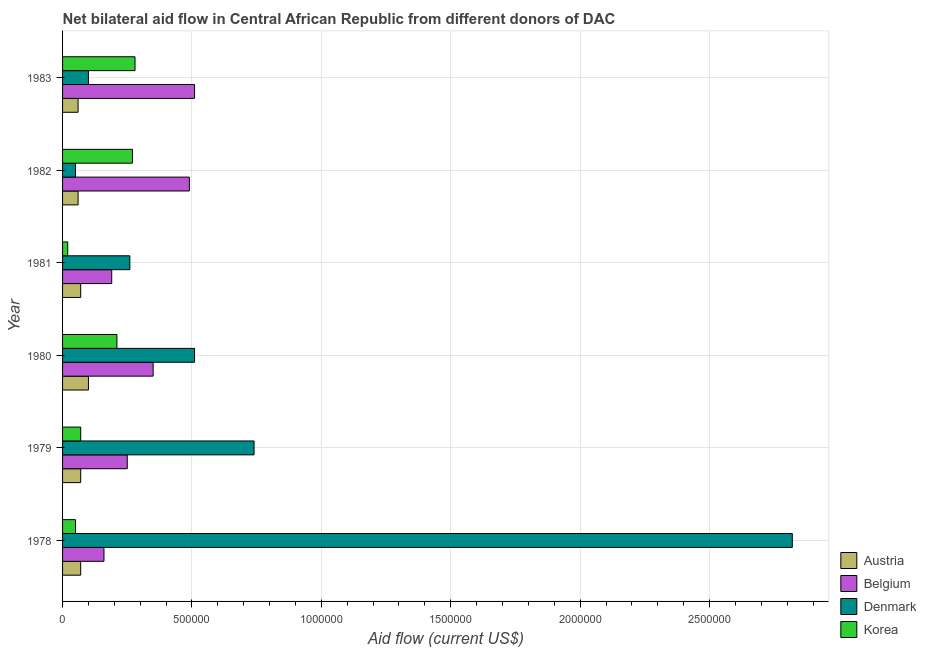Are the number of bars per tick equal to the number of legend labels?
Give a very brief answer. Yes. How many bars are there on the 4th tick from the top?
Provide a short and direct response. 4. How many bars are there on the 1st tick from the bottom?
Provide a short and direct response. 4. What is the amount of aid given by belgium in 1981?
Your answer should be very brief. 1.90e+05. Across all years, what is the maximum amount of aid given by austria?
Your answer should be very brief. 1.00e+05. Across all years, what is the minimum amount of aid given by korea?
Your answer should be compact. 2.00e+04. In which year was the amount of aid given by belgium maximum?
Offer a very short reply. 1983. In which year was the amount of aid given by korea minimum?
Your answer should be very brief. 1981. What is the total amount of aid given by austria in the graph?
Provide a succinct answer. 4.30e+05. What is the difference between the amount of aid given by belgium in 1980 and that in 1982?
Your answer should be compact. -1.40e+05. What is the difference between the amount of aid given by austria in 1982 and the amount of aid given by belgium in 1983?
Your response must be concise. -4.50e+05. What is the average amount of aid given by belgium per year?
Give a very brief answer. 3.25e+05. In the year 1981, what is the difference between the amount of aid given by austria and amount of aid given by denmark?
Provide a succinct answer. -1.90e+05. In how many years, is the amount of aid given by korea greater than 2200000 US$?
Provide a succinct answer. 0. What is the ratio of the amount of aid given by denmark in 1978 to that in 1982?
Your response must be concise. 56.4. Is the amount of aid given by korea in 1982 less than that in 1983?
Offer a terse response. Yes. Is the difference between the amount of aid given by austria in 1980 and 1982 greater than the difference between the amount of aid given by belgium in 1980 and 1982?
Provide a succinct answer. Yes. What is the difference between the highest and the lowest amount of aid given by belgium?
Your answer should be compact. 3.50e+05. In how many years, is the amount of aid given by austria greater than the average amount of aid given by austria taken over all years?
Give a very brief answer. 1. Is it the case that in every year, the sum of the amount of aid given by denmark and amount of aid given by korea is greater than the sum of amount of aid given by austria and amount of aid given by belgium?
Keep it short and to the point. No. What does the 2nd bar from the bottom in 1981 represents?
Your answer should be very brief. Belgium. Is it the case that in every year, the sum of the amount of aid given by austria and amount of aid given by belgium is greater than the amount of aid given by denmark?
Give a very brief answer. No. How many bars are there?
Your answer should be compact. 24. What is the difference between two consecutive major ticks on the X-axis?
Offer a very short reply. 5.00e+05. Does the graph contain grids?
Provide a short and direct response. Yes. Where does the legend appear in the graph?
Make the answer very short. Bottom right. What is the title of the graph?
Offer a terse response. Net bilateral aid flow in Central African Republic from different donors of DAC. What is the label or title of the Y-axis?
Your response must be concise. Year. What is the Aid flow (current US$) of Denmark in 1978?
Provide a succinct answer. 2.82e+06. What is the Aid flow (current US$) of Korea in 1978?
Your answer should be very brief. 5.00e+04. What is the Aid flow (current US$) in Denmark in 1979?
Your answer should be compact. 7.40e+05. What is the Aid flow (current US$) in Denmark in 1980?
Your response must be concise. 5.10e+05. What is the Aid flow (current US$) of Belgium in 1981?
Provide a short and direct response. 1.90e+05. What is the Aid flow (current US$) in Denmark in 1981?
Your answer should be very brief. 2.60e+05. What is the Aid flow (current US$) in Austria in 1982?
Offer a very short reply. 6.00e+04. What is the Aid flow (current US$) in Belgium in 1982?
Offer a very short reply. 4.90e+05. What is the Aid flow (current US$) in Denmark in 1982?
Your answer should be very brief. 5.00e+04. What is the Aid flow (current US$) in Korea in 1982?
Keep it short and to the point. 2.70e+05. What is the Aid flow (current US$) in Austria in 1983?
Your response must be concise. 6.00e+04. What is the Aid flow (current US$) in Belgium in 1983?
Ensure brevity in your answer.  5.10e+05. Across all years, what is the maximum Aid flow (current US$) in Austria?
Offer a terse response. 1.00e+05. Across all years, what is the maximum Aid flow (current US$) of Belgium?
Make the answer very short. 5.10e+05. Across all years, what is the maximum Aid flow (current US$) in Denmark?
Make the answer very short. 2.82e+06. Across all years, what is the maximum Aid flow (current US$) of Korea?
Offer a very short reply. 2.80e+05. Across all years, what is the minimum Aid flow (current US$) in Austria?
Your answer should be very brief. 6.00e+04. Across all years, what is the minimum Aid flow (current US$) of Denmark?
Your answer should be very brief. 5.00e+04. Across all years, what is the minimum Aid flow (current US$) of Korea?
Provide a succinct answer. 2.00e+04. What is the total Aid flow (current US$) of Austria in the graph?
Offer a very short reply. 4.30e+05. What is the total Aid flow (current US$) in Belgium in the graph?
Ensure brevity in your answer.  1.95e+06. What is the total Aid flow (current US$) of Denmark in the graph?
Keep it short and to the point. 4.48e+06. What is the difference between the Aid flow (current US$) of Austria in 1978 and that in 1979?
Ensure brevity in your answer.  0. What is the difference between the Aid flow (current US$) of Belgium in 1978 and that in 1979?
Offer a very short reply. -9.00e+04. What is the difference between the Aid flow (current US$) of Denmark in 1978 and that in 1979?
Give a very brief answer. 2.08e+06. What is the difference between the Aid flow (current US$) of Austria in 1978 and that in 1980?
Your answer should be compact. -3.00e+04. What is the difference between the Aid flow (current US$) in Belgium in 1978 and that in 1980?
Make the answer very short. -1.90e+05. What is the difference between the Aid flow (current US$) in Denmark in 1978 and that in 1980?
Your answer should be very brief. 2.31e+06. What is the difference between the Aid flow (current US$) in Korea in 1978 and that in 1980?
Your answer should be very brief. -1.60e+05. What is the difference between the Aid flow (current US$) in Denmark in 1978 and that in 1981?
Keep it short and to the point. 2.56e+06. What is the difference between the Aid flow (current US$) in Korea in 1978 and that in 1981?
Ensure brevity in your answer.  3.00e+04. What is the difference between the Aid flow (current US$) in Austria in 1978 and that in 1982?
Make the answer very short. 10000. What is the difference between the Aid flow (current US$) of Belgium in 1978 and that in 1982?
Offer a terse response. -3.30e+05. What is the difference between the Aid flow (current US$) of Denmark in 1978 and that in 1982?
Ensure brevity in your answer.  2.77e+06. What is the difference between the Aid flow (current US$) in Korea in 1978 and that in 1982?
Make the answer very short. -2.20e+05. What is the difference between the Aid flow (current US$) in Belgium in 1978 and that in 1983?
Your response must be concise. -3.50e+05. What is the difference between the Aid flow (current US$) in Denmark in 1978 and that in 1983?
Offer a very short reply. 2.72e+06. What is the difference between the Aid flow (current US$) of Belgium in 1979 and that in 1980?
Provide a short and direct response. -1.00e+05. What is the difference between the Aid flow (current US$) in Denmark in 1979 and that in 1980?
Provide a succinct answer. 2.30e+05. What is the difference between the Aid flow (current US$) of Korea in 1979 and that in 1980?
Make the answer very short. -1.40e+05. What is the difference between the Aid flow (current US$) in Austria in 1979 and that in 1981?
Your answer should be compact. 0. What is the difference between the Aid flow (current US$) in Austria in 1979 and that in 1982?
Your answer should be very brief. 10000. What is the difference between the Aid flow (current US$) of Belgium in 1979 and that in 1982?
Ensure brevity in your answer.  -2.40e+05. What is the difference between the Aid flow (current US$) in Denmark in 1979 and that in 1982?
Provide a short and direct response. 6.90e+05. What is the difference between the Aid flow (current US$) of Korea in 1979 and that in 1982?
Offer a terse response. -2.00e+05. What is the difference between the Aid flow (current US$) of Austria in 1979 and that in 1983?
Your response must be concise. 10000. What is the difference between the Aid flow (current US$) of Belgium in 1979 and that in 1983?
Ensure brevity in your answer.  -2.60e+05. What is the difference between the Aid flow (current US$) in Denmark in 1979 and that in 1983?
Your response must be concise. 6.40e+05. What is the difference between the Aid flow (current US$) in Korea in 1979 and that in 1983?
Offer a terse response. -2.10e+05. What is the difference between the Aid flow (current US$) of Austria in 1980 and that in 1981?
Your answer should be compact. 3.00e+04. What is the difference between the Aid flow (current US$) of Belgium in 1980 and that in 1982?
Ensure brevity in your answer.  -1.40e+05. What is the difference between the Aid flow (current US$) of Denmark in 1980 and that in 1982?
Offer a very short reply. 4.60e+05. What is the difference between the Aid flow (current US$) in Korea in 1980 and that in 1982?
Give a very brief answer. -6.00e+04. What is the difference between the Aid flow (current US$) of Austria in 1980 and that in 1983?
Your answer should be very brief. 4.00e+04. What is the difference between the Aid flow (current US$) in Belgium in 1980 and that in 1983?
Give a very brief answer. -1.60e+05. What is the difference between the Aid flow (current US$) of Denmark in 1980 and that in 1983?
Give a very brief answer. 4.10e+05. What is the difference between the Aid flow (current US$) in Korea in 1981 and that in 1982?
Keep it short and to the point. -2.50e+05. What is the difference between the Aid flow (current US$) of Belgium in 1981 and that in 1983?
Provide a succinct answer. -3.20e+05. What is the difference between the Aid flow (current US$) in Korea in 1981 and that in 1983?
Keep it short and to the point. -2.60e+05. What is the difference between the Aid flow (current US$) in Austria in 1982 and that in 1983?
Your answer should be very brief. 0. What is the difference between the Aid flow (current US$) in Austria in 1978 and the Aid flow (current US$) in Denmark in 1979?
Give a very brief answer. -6.70e+05. What is the difference between the Aid flow (current US$) in Belgium in 1978 and the Aid flow (current US$) in Denmark in 1979?
Ensure brevity in your answer.  -5.80e+05. What is the difference between the Aid flow (current US$) of Belgium in 1978 and the Aid flow (current US$) of Korea in 1979?
Your answer should be very brief. 9.00e+04. What is the difference between the Aid flow (current US$) of Denmark in 1978 and the Aid flow (current US$) of Korea in 1979?
Make the answer very short. 2.75e+06. What is the difference between the Aid flow (current US$) of Austria in 1978 and the Aid flow (current US$) of Belgium in 1980?
Offer a terse response. -2.80e+05. What is the difference between the Aid flow (current US$) in Austria in 1978 and the Aid flow (current US$) in Denmark in 1980?
Make the answer very short. -4.40e+05. What is the difference between the Aid flow (current US$) in Belgium in 1978 and the Aid flow (current US$) in Denmark in 1980?
Your answer should be compact. -3.50e+05. What is the difference between the Aid flow (current US$) in Denmark in 1978 and the Aid flow (current US$) in Korea in 1980?
Keep it short and to the point. 2.61e+06. What is the difference between the Aid flow (current US$) of Belgium in 1978 and the Aid flow (current US$) of Denmark in 1981?
Your answer should be very brief. -1.00e+05. What is the difference between the Aid flow (current US$) of Denmark in 1978 and the Aid flow (current US$) of Korea in 1981?
Your answer should be very brief. 2.80e+06. What is the difference between the Aid flow (current US$) of Austria in 1978 and the Aid flow (current US$) of Belgium in 1982?
Provide a succinct answer. -4.20e+05. What is the difference between the Aid flow (current US$) of Austria in 1978 and the Aid flow (current US$) of Denmark in 1982?
Provide a short and direct response. 2.00e+04. What is the difference between the Aid flow (current US$) in Belgium in 1978 and the Aid flow (current US$) in Denmark in 1982?
Your answer should be very brief. 1.10e+05. What is the difference between the Aid flow (current US$) in Denmark in 1978 and the Aid flow (current US$) in Korea in 1982?
Provide a short and direct response. 2.55e+06. What is the difference between the Aid flow (current US$) of Austria in 1978 and the Aid flow (current US$) of Belgium in 1983?
Offer a terse response. -4.40e+05. What is the difference between the Aid flow (current US$) in Denmark in 1978 and the Aid flow (current US$) in Korea in 1983?
Keep it short and to the point. 2.54e+06. What is the difference between the Aid flow (current US$) in Austria in 1979 and the Aid flow (current US$) in Belgium in 1980?
Your answer should be compact. -2.80e+05. What is the difference between the Aid flow (current US$) of Austria in 1979 and the Aid flow (current US$) of Denmark in 1980?
Offer a very short reply. -4.40e+05. What is the difference between the Aid flow (current US$) in Belgium in 1979 and the Aid flow (current US$) in Korea in 1980?
Offer a terse response. 4.00e+04. What is the difference between the Aid flow (current US$) in Denmark in 1979 and the Aid flow (current US$) in Korea in 1980?
Offer a very short reply. 5.30e+05. What is the difference between the Aid flow (current US$) in Austria in 1979 and the Aid flow (current US$) in Denmark in 1981?
Give a very brief answer. -1.90e+05. What is the difference between the Aid flow (current US$) of Belgium in 1979 and the Aid flow (current US$) of Denmark in 1981?
Your answer should be very brief. -10000. What is the difference between the Aid flow (current US$) in Denmark in 1979 and the Aid flow (current US$) in Korea in 1981?
Keep it short and to the point. 7.20e+05. What is the difference between the Aid flow (current US$) of Austria in 1979 and the Aid flow (current US$) of Belgium in 1982?
Offer a terse response. -4.20e+05. What is the difference between the Aid flow (current US$) in Austria in 1979 and the Aid flow (current US$) in Denmark in 1982?
Give a very brief answer. 2.00e+04. What is the difference between the Aid flow (current US$) of Austria in 1979 and the Aid flow (current US$) of Korea in 1982?
Your response must be concise. -2.00e+05. What is the difference between the Aid flow (current US$) in Belgium in 1979 and the Aid flow (current US$) in Denmark in 1982?
Ensure brevity in your answer.  2.00e+05. What is the difference between the Aid flow (current US$) of Denmark in 1979 and the Aid flow (current US$) of Korea in 1982?
Keep it short and to the point. 4.70e+05. What is the difference between the Aid flow (current US$) of Austria in 1979 and the Aid flow (current US$) of Belgium in 1983?
Give a very brief answer. -4.40e+05. What is the difference between the Aid flow (current US$) in Belgium in 1979 and the Aid flow (current US$) in Denmark in 1983?
Make the answer very short. 1.50e+05. What is the difference between the Aid flow (current US$) of Austria in 1980 and the Aid flow (current US$) of Denmark in 1981?
Provide a short and direct response. -1.60e+05. What is the difference between the Aid flow (current US$) in Austria in 1980 and the Aid flow (current US$) in Korea in 1981?
Ensure brevity in your answer.  8.00e+04. What is the difference between the Aid flow (current US$) in Belgium in 1980 and the Aid flow (current US$) in Denmark in 1981?
Keep it short and to the point. 9.00e+04. What is the difference between the Aid flow (current US$) in Denmark in 1980 and the Aid flow (current US$) in Korea in 1981?
Offer a very short reply. 4.90e+05. What is the difference between the Aid flow (current US$) of Austria in 1980 and the Aid flow (current US$) of Belgium in 1982?
Your answer should be very brief. -3.90e+05. What is the difference between the Aid flow (current US$) in Austria in 1980 and the Aid flow (current US$) in Korea in 1982?
Give a very brief answer. -1.70e+05. What is the difference between the Aid flow (current US$) of Belgium in 1980 and the Aid flow (current US$) of Denmark in 1982?
Offer a very short reply. 3.00e+05. What is the difference between the Aid flow (current US$) of Austria in 1980 and the Aid flow (current US$) of Belgium in 1983?
Offer a terse response. -4.10e+05. What is the difference between the Aid flow (current US$) in Austria in 1980 and the Aid flow (current US$) in Denmark in 1983?
Offer a terse response. 0. What is the difference between the Aid flow (current US$) of Austria in 1980 and the Aid flow (current US$) of Korea in 1983?
Your answer should be very brief. -1.80e+05. What is the difference between the Aid flow (current US$) in Denmark in 1980 and the Aid flow (current US$) in Korea in 1983?
Keep it short and to the point. 2.30e+05. What is the difference between the Aid flow (current US$) in Austria in 1981 and the Aid flow (current US$) in Belgium in 1982?
Your answer should be very brief. -4.20e+05. What is the difference between the Aid flow (current US$) in Austria in 1981 and the Aid flow (current US$) in Korea in 1982?
Ensure brevity in your answer.  -2.00e+05. What is the difference between the Aid flow (current US$) of Belgium in 1981 and the Aid flow (current US$) of Korea in 1982?
Make the answer very short. -8.00e+04. What is the difference between the Aid flow (current US$) in Denmark in 1981 and the Aid flow (current US$) in Korea in 1982?
Your response must be concise. -10000. What is the difference between the Aid flow (current US$) in Austria in 1981 and the Aid flow (current US$) in Belgium in 1983?
Offer a very short reply. -4.40e+05. What is the difference between the Aid flow (current US$) of Austria in 1981 and the Aid flow (current US$) of Korea in 1983?
Give a very brief answer. -2.10e+05. What is the difference between the Aid flow (current US$) of Belgium in 1981 and the Aid flow (current US$) of Denmark in 1983?
Provide a short and direct response. 9.00e+04. What is the difference between the Aid flow (current US$) of Denmark in 1981 and the Aid flow (current US$) of Korea in 1983?
Provide a succinct answer. -2.00e+04. What is the difference between the Aid flow (current US$) in Austria in 1982 and the Aid flow (current US$) in Belgium in 1983?
Your response must be concise. -4.50e+05. What is the difference between the Aid flow (current US$) of Belgium in 1982 and the Aid flow (current US$) of Korea in 1983?
Your answer should be compact. 2.10e+05. What is the difference between the Aid flow (current US$) in Denmark in 1982 and the Aid flow (current US$) in Korea in 1983?
Make the answer very short. -2.30e+05. What is the average Aid flow (current US$) of Austria per year?
Your answer should be very brief. 7.17e+04. What is the average Aid flow (current US$) in Belgium per year?
Make the answer very short. 3.25e+05. What is the average Aid flow (current US$) of Denmark per year?
Offer a terse response. 7.47e+05. In the year 1978, what is the difference between the Aid flow (current US$) of Austria and Aid flow (current US$) of Belgium?
Give a very brief answer. -9.00e+04. In the year 1978, what is the difference between the Aid flow (current US$) in Austria and Aid flow (current US$) in Denmark?
Offer a terse response. -2.75e+06. In the year 1978, what is the difference between the Aid flow (current US$) in Belgium and Aid flow (current US$) in Denmark?
Offer a terse response. -2.66e+06. In the year 1978, what is the difference between the Aid flow (current US$) in Denmark and Aid flow (current US$) in Korea?
Give a very brief answer. 2.77e+06. In the year 1979, what is the difference between the Aid flow (current US$) in Austria and Aid flow (current US$) in Denmark?
Offer a very short reply. -6.70e+05. In the year 1979, what is the difference between the Aid flow (current US$) in Austria and Aid flow (current US$) in Korea?
Ensure brevity in your answer.  0. In the year 1979, what is the difference between the Aid flow (current US$) in Belgium and Aid flow (current US$) in Denmark?
Offer a terse response. -4.90e+05. In the year 1979, what is the difference between the Aid flow (current US$) of Belgium and Aid flow (current US$) of Korea?
Make the answer very short. 1.80e+05. In the year 1979, what is the difference between the Aid flow (current US$) of Denmark and Aid flow (current US$) of Korea?
Give a very brief answer. 6.70e+05. In the year 1980, what is the difference between the Aid flow (current US$) in Austria and Aid flow (current US$) in Denmark?
Your response must be concise. -4.10e+05. In the year 1980, what is the difference between the Aid flow (current US$) of Belgium and Aid flow (current US$) of Denmark?
Offer a terse response. -1.60e+05. In the year 1980, what is the difference between the Aid flow (current US$) of Belgium and Aid flow (current US$) of Korea?
Offer a very short reply. 1.40e+05. In the year 1980, what is the difference between the Aid flow (current US$) in Denmark and Aid flow (current US$) in Korea?
Make the answer very short. 3.00e+05. In the year 1981, what is the difference between the Aid flow (current US$) of Austria and Aid flow (current US$) of Belgium?
Your answer should be compact. -1.20e+05. In the year 1981, what is the difference between the Aid flow (current US$) of Belgium and Aid flow (current US$) of Denmark?
Offer a terse response. -7.00e+04. In the year 1982, what is the difference between the Aid flow (current US$) in Austria and Aid flow (current US$) in Belgium?
Your answer should be compact. -4.30e+05. In the year 1982, what is the difference between the Aid flow (current US$) in Austria and Aid flow (current US$) in Korea?
Ensure brevity in your answer.  -2.10e+05. In the year 1982, what is the difference between the Aid flow (current US$) in Belgium and Aid flow (current US$) in Korea?
Offer a terse response. 2.20e+05. In the year 1982, what is the difference between the Aid flow (current US$) of Denmark and Aid flow (current US$) of Korea?
Offer a very short reply. -2.20e+05. In the year 1983, what is the difference between the Aid flow (current US$) of Austria and Aid flow (current US$) of Belgium?
Offer a terse response. -4.50e+05. In the year 1983, what is the difference between the Aid flow (current US$) of Austria and Aid flow (current US$) of Denmark?
Your answer should be compact. -4.00e+04. In the year 1983, what is the difference between the Aid flow (current US$) in Austria and Aid flow (current US$) in Korea?
Your response must be concise. -2.20e+05. In the year 1983, what is the difference between the Aid flow (current US$) in Belgium and Aid flow (current US$) in Denmark?
Provide a short and direct response. 4.10e+05. In the year 1983, what is the difference between the Aid flow (current US$) of Denmark and Aid flow (current US$) of Korea?
Give a very brief answer. -1.80e+05. What is the ratio of the Aid flow (current US$) in Austria in 1978 to that in 1979?
Offer a terse response. 1. What is the ratio of the Aid flow (current US$) of Belgium in 1978 to that in 1979?
Your response must be concise. 0.64. What is the ratio of the Aid flow (current US$) of Denmark in 1978 to that in 1979?
Make the answer very short. 3.81. What is the ratio of the Aid flow (current US$) in Belgium in 1978 to that in 1980?
Provide a short and direct response. 0.46. What is the ratio of the Aid flow (current US$) of Denmark in 1978 to that in 1980?
Offer a very short reply. 5.53. What is the ratio of the Aid flow (current US$) in Korea in 1978 to that in 1980?
Give a very brief answer. 0.24. What is the ratio of the Aid flow (current US$) of Austria in 1978 to that in 1981?
Ensure brevity in your answer.  1. What is the ratio of the Aid flow (current US$) in Belgium in 1978 to that in 1981?
Provide a short and direct response. 0.84. What is the ratio of the Aid flow (current US$) of Denmark in 1978 to that in 1981?
Offer a terse response. 10.85. What is the ratio of the Aid flow (current US$) in Korea in 1978 to that in 1981?
Provide a short and direct response. 2.5. What is the ratio of the Aid flow (current US$) of Belgium in 1978 to that in 1982?
Give a very brief answer. 0.33. What is the ratio of the Aid flow (current US$) in Denmark in 1978 to that in 1982?
Offer a very short reply. 56.4. What is the ratio of the Aid flow (current US$) of Korea in 1978 to that in 1982?
Give a very brief answer. 0.19. What is the ratio of the Aid flow (current US$) in Austria in 1978 to that in 1983?
Offer a terse response. 1.17. What is the ratio of the Aid flow (current US$) of Belgium in 1978 to that in 1983?
Your answer should be compact. 0.31. What is the ratio of the Aid flow (current US$) of Denmark in 1978 to that in 1983?
Provide a short and direct response. 28.2. What is the ratio of the Aid flow (current US$) of Korea in 1978 to that in 1983?
Offer a terse response. 0.18. What is the ratio of the Aid flow (current US$) of Belgium in 1979 to that in 1980?
Ensure brevity in your answer.  0.71. What is the ratio of the Aid flow (current US$) in Denmark in 1979 to that in 1980?
Provide a succinct answer. 1.45. What is the ratio of the Aid flow (current US$) in Belgium in 1979 to that in 1981?
Provide a short and direct response. 1.32. What is the ratio of the Aid flow (current US$) in Denmark in 1979 to that in 1981?
Provide a succinct answer. 2.85. What is the ratio of the Aid flow (current US$) in Austria in 1979 to that in 1982?
Offer a very short reply. 1.17. What is the ratio of the Aid flow (current US$) of Belgium in 1979 to that in 1982?
Provide a succinct answer. 0.51. What is the ratio of the Aid flow (current US$) of Korea in 1979 to that in 1982?
Ensure brevity in your answer.  0.26. What is the ratio of the Aid flow (current US$) in Belgium in 1979 to that in 1983?
Ensure brevity in your answer.  0.49. What is the ratio of the Aid flow (current US$) in Korea in 1979 to that in 1983?
Your answer should be compact. 0.25. What is the ratio of the Aid flow (current US$) of Austria in 1980 to that in 1981?
Make the answer very short. 1.43. What is the ratio of the Aid flow (current US$) of Belgium in 1980 to that in 1981?
Make the answer very short. 1.84. What is the ratio of the Aid flow (current US$) in Denmark in 1980 to that in 1981?
Provide a short and direct response. 1.96. What is the ratio of the Aid flow (current US$) of Korea in 1980 to that in 1981?
Offer a very short reply. 10.5. What is the ratio of the Aid flow (current US$) in Belgium in 1980 to that in 1982?
Your response must be concise. 0.71. What is the ratio of the Aid flow (current US$) in Denmark in 1980 to that in 1982?
Ensure brevity in your answer.  10.2. What is the ratio of the Aid flow (current US$) in Korea in 1980 to that in 1982?
Give a very brief answer. 0.78. What is the ratio of the Aid flow (current US$) in Belgium in 1980 to that in 1983?
Ensure brevity in your answer.  0.69. What is the ratio of the Aid flow (current US$) in Korea in 1980 to that in 1983?
Provide a short and direct response. 0.75. What is the ratio of the Aid flow (current US$) of Austria in 1981 to that in 1982?
Make the answer very short. 1.17. What is the ratio of the Aid flow (current US$) in Belgium in 1981 to that in 1982?
Give a very brief answer. 0.39. What is the ratio of the Aid flow (current US$) in Denmark in 1981 to that in 1982?
Provide a short and direct response. 5.2. What is the ratio of the Aid flow (current US$) of Korea in 1981 to that in 1982?
Your answer should be compact. 0.07. What is the ratio of the Aid flow (current US$) of Austria in 1981 to that in 1983?
Your response must be concise. 1.17. What is the ratio of the Aid flow (current US$) of Belgium in 1981 to that in 1983?
Ensure brevity in your answer.  0.37. What is the ratio of the Aid flow (current US$) in Korea in 1981 to that in 1983?
Offer a terse response. 0.07. What is the ratio of the Aid flow (current US$) in Austria in 1982 to that in 1983?
Your answer should be compact. 1. What is the ratio of the Aid flow (current US$) of Belgium in 1982 to that in 1983?
Your answer should be compact. 0.96. What is the ratio of the Aid flow (current US$) in Korea in 1982 to that in 1983?
Your answer should be compact. 0.96. What is the difference between the highest and the second highest Aid flow (current US$) in Belgium?
Provide a succinct answer. 2.00e+04. What is the difference between the highest and the second highest Aid flow (current US$) in Denmark?
Offer a very short reply. 2.08e+06. What is the difference between the highest and the second highest Aid flow (current US$) in Korea?
Offer a terse response. 10000. What is the difference between the highest and the lowest Aid flow (current US$) of Belgium?
Your answer should be compact. 3.50e+05. What is the difference between the highest and the lowest Aid flow (current US$) of Denmark?
Your answer should be very brief. 2.77e+06. What is the difference between the highest and the lowest Aid flow (current US$) in Korea?
Your answer should be very brief. 2.60e+05. 